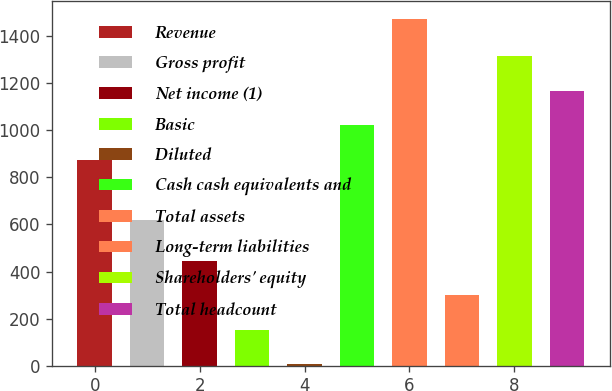<chart> <loc_0><loc_0><loc_500><loc_500><bar_chart><fcel>Revenue<fcel>Gross profit<fcel>Net income (1)<fcel>Basic<fcel>Diluted<fcel>Cash cash equivalents and<fcel>Total assets<fcel>Long-term liabilities<fcel>Shareholders' equity<fcel>Total headcount<nl><fcel>874.9<fcel>620.8<fcel>445.97<fcel>152.07<fcel>5.12<fcel>1021.85<fcel>1474.6<fcel>299.02<fcel>1315.75<fcel>1168.8<nl></chart> 